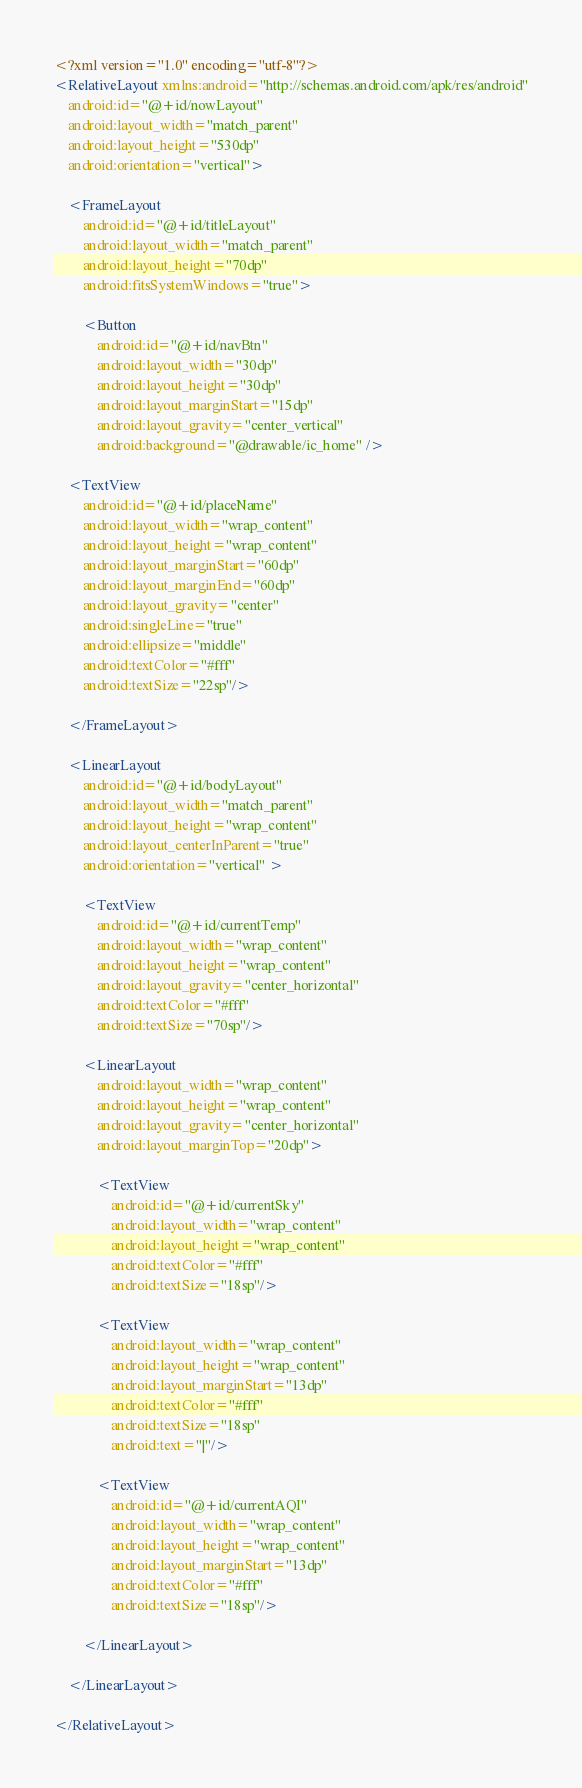Convert code to text. <code><loc_0><loc_0><loc_500><loc_500><_XML_><?xml version="1.0" encoding="utf-8"?>
<RelativeLayout xmlns:android="http://schemas.android.com/apk/res/android"
    android:id="@+id/nowLayout"
    android:layout_width="match_parent"
    android:layout_height="530dp"
    android:orientation="vertical">

    <FrameLayout
        android:id="@+id/titleLayout"
        android:layout_width="match_parent"
        android:layout_height="70dp"
        android:fitsSystemWindows="true">

        <Button
            android:id="@+id/navBtn"
            android:layout_width="30dp"
            android:layout_height="30dp"
            android:layout_marginStart="15dp"
            android:layout_gravity="center_vertical"
            android:background="@drawable/ic_home" />

    <TextView
        android:id="@+id/placeName"
        android:layout_width="wrap_content"
        android:layout_height="wrap_content"
        android:layout_marginStart="60dp"
        android:layout_marginEnd="60dp"
        android:layout_gravity="center"
        android:singleLine="true"
        android:ellipsize="middle"
        android:textColor="#fff"
        android:textSize="22sp"/>

    </FrameLayout>

    <LinearLayout
        android:id="@+id/bodyLayout"
        android:layout_width="match_parent"
        android:layout_height="wrap_content"
        android:layout_centerInParent="true"
        android:orientation="vertical" >

        <TextView
            android:id="@+id/currentTemp"
            android:layout_width="wrap_content"
            android:layout_height="wrap_content"
            android:layout_gravity="center_horizontal"
            android:textColor="#fff"
            android:textSize="70sp"/>

        <LinearLayout
            android:layout_width="wrap_content"
            android:layout_height="wrap_content"
            android:layout_gravity="center_horizontal"
            android:layout_marginTop="20dp">

            <TextView
                android:id="@+id/currentSky"
                android:layout_width="wrap_content"
                android:layout_height="wrap_content"
                android:textColor="#fff"
                android:textSize="18sp"/>

            <TextView
                android:layout_width="wrap_content"
                android:layout_height="wrap_content"
                android:layout_marginStart="13dp"
                android:textColor="#fff"
                android:textSize="18sp"
                android:text="|"/>

            <TextView
                android:id="@+id/currentAQI"
                android:layout_width="wrap_content"
                android:layout_height="wrap_content"
                android:layout_marginStart="13dp"
                android:textColor="#fff"
                android:textSize="18sp"/>

        </LinearLayout>

    </LinearLayout>

</RelativeLayout></code> 